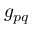<formula> <loc_0><loc_0><loc_500><loc_500>g _ { p q }</formula> 